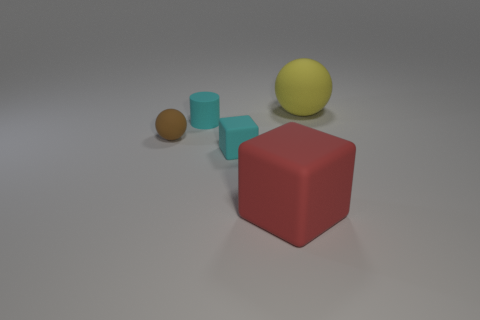Add 1 large brown rubber cylinders. How many objects exist? 6 Subtract all cylinders. How many objects are left? 4 Subtract 1 cylinders. How many cylinders are left? 0 Subtract all yellow spheres. How many spheres are left? 1 Subtract 0 yellow cylinders. How many objects are left? 5 Subtract all brown spheres. Subtract all red blocks. How many spheres are left? 1 Subtract all gray cubes. How many yellow balls are left? 1 Subtract all big matte things. Subtract all brown spheres. How many objects are left? 2 Add 2 small brown rubber balls. How many small brown rubber balls are left? 3 Add 1 gray metallic spheres. How many gray metallic spheres exist? 1 